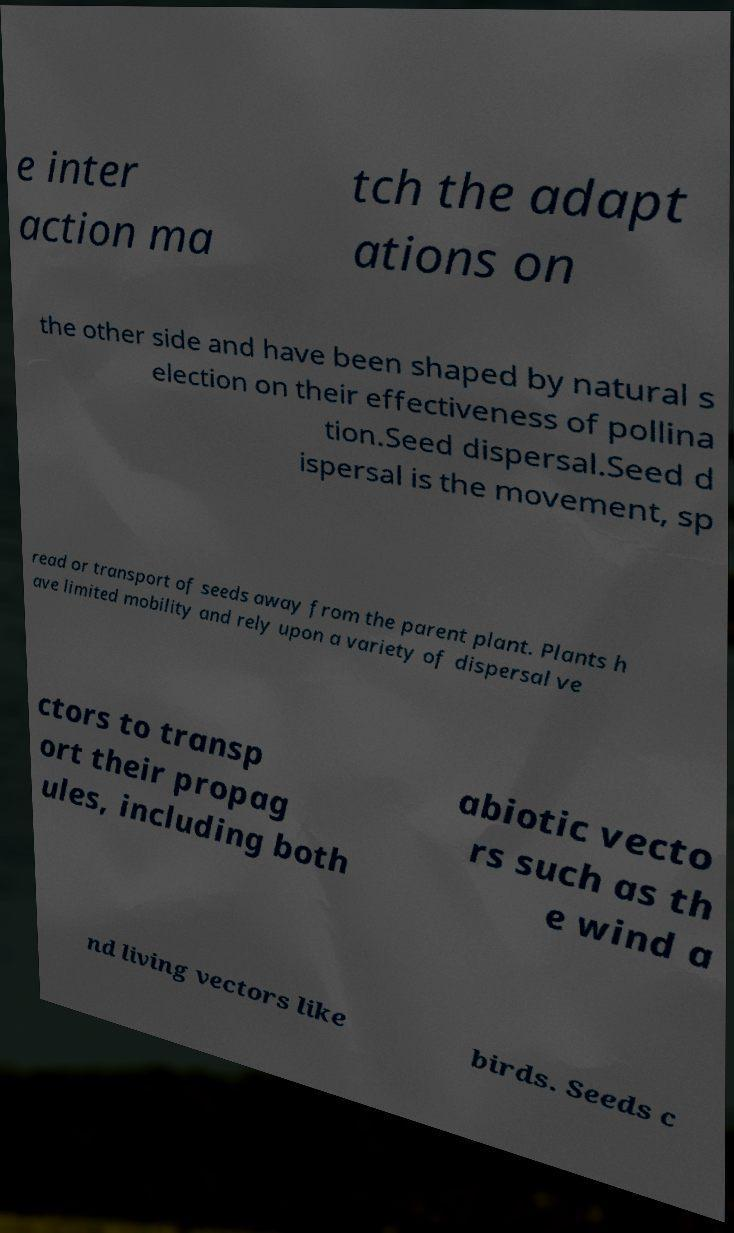There's text embedded in this image that I need extracted. Can you transcribe it verbatim? e inter action ma tch the adapt ations on the other side and have been shaped by natural s election on their effectiveness of pollina tion.Seed dispersal.Seed d ispersal is the movement, sp read or transport of seeds away from the parent plant. Plants h ave limited mobility and rely upon a variety of dispersal ve ctors to transp ort their propag ules, including both abiotic vecto rs such as th e wind a nd living vectors like birds. Seeds c 